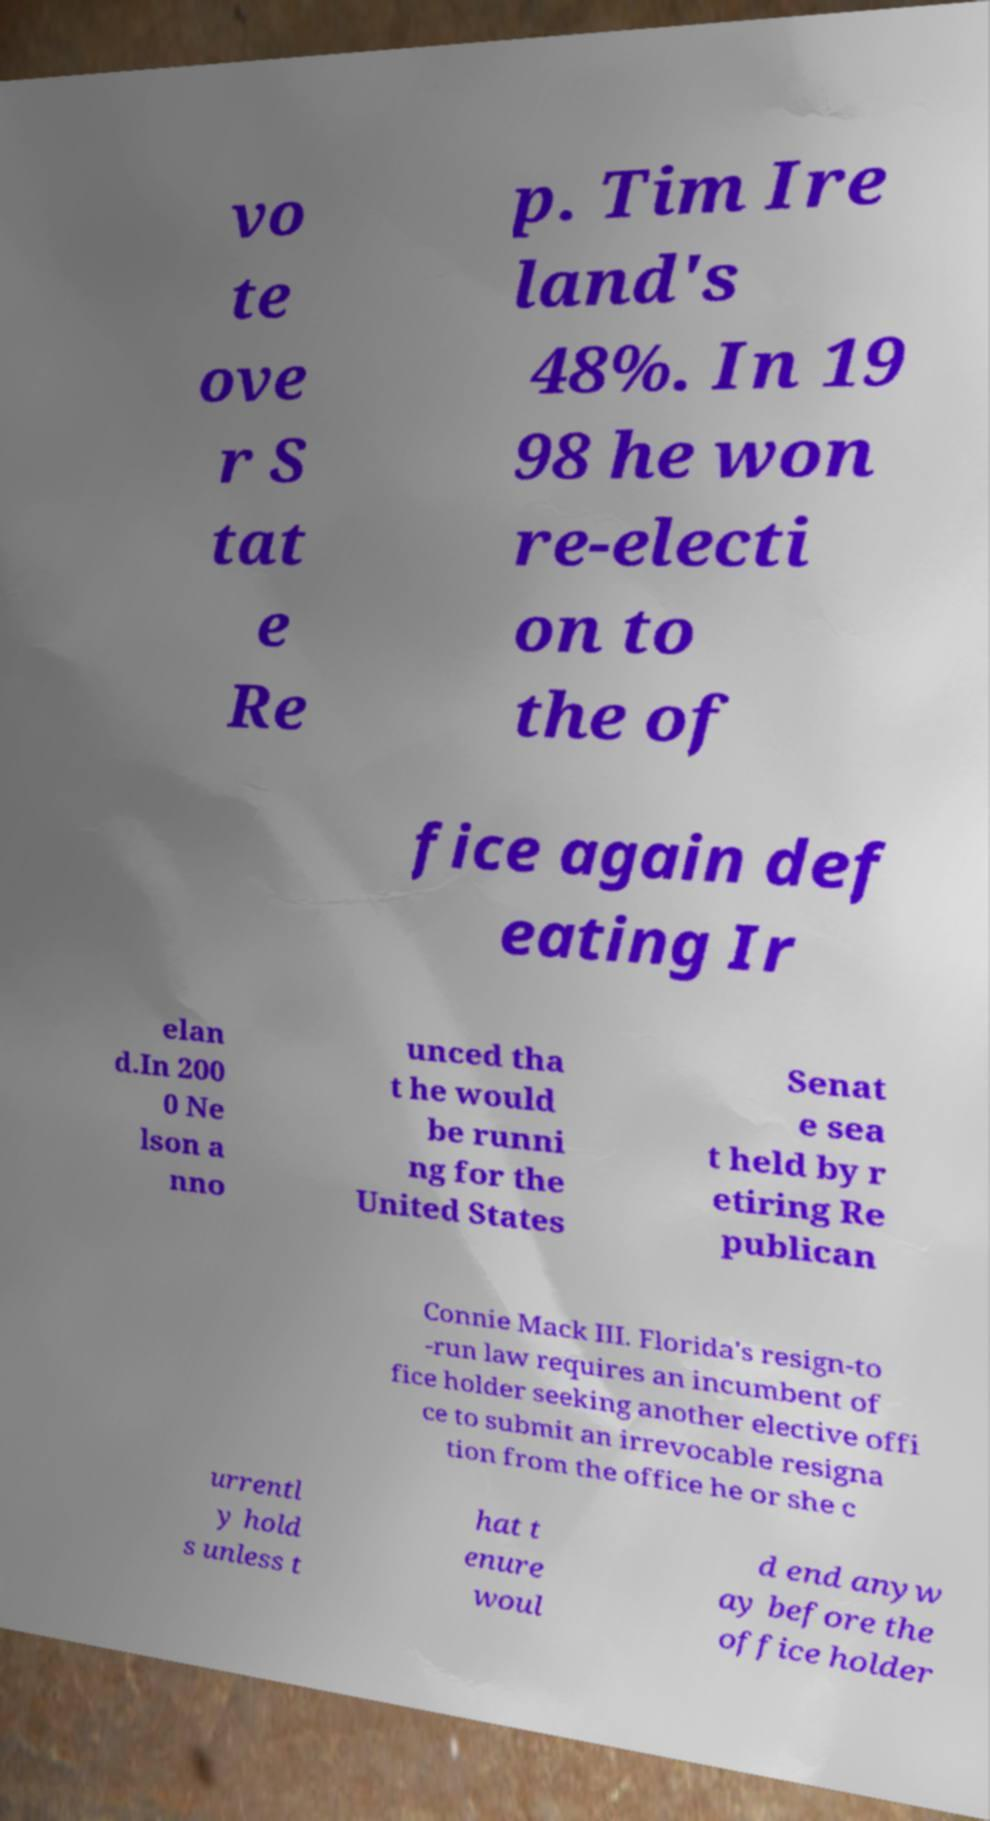Please read and relay the text visible in this image. What does it say? vo te ove r S tat e Re p. Tim Ire land's 48%. In 19 98 he won re-electi on to the of fice again def eating Ir elan d.In 200 0 Ne lson a nno unced tha t he would be runni ng for the United States Senat e sea t held by r etiring Re publican Connie Mack III. Florida's resign-to -run law requires an incumbent of fice holder seeking another elective offi ce to submit an irrevocable resigna tion from the office he or she c urrentl y hold s unless t hat t enure woul d end anyw ay before the office holder 